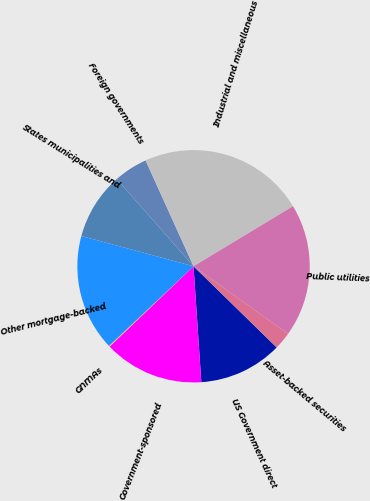Convert chart. <chart><loc_0><loc_0><loc_500><loc_500><pie_chart><fcel>US Government direct<fcel>Government-sponsored<fcel>GNMAs<fcel>Other mortgage-backed<fcel>States municipalities and<fcel>Foreign governments<fcel>Industrial and miscellaneous<fcel>Public utilities<fcel>Asset-backed securities<nl><fcel>11.62%<fcel>13.92%<fcel>0.12%<fcel>16.22%<fcel>9.32%<fcel>4.72%<fcel>23.13%<fcel>18.53%<fcel>2.42%<nl></chart> 